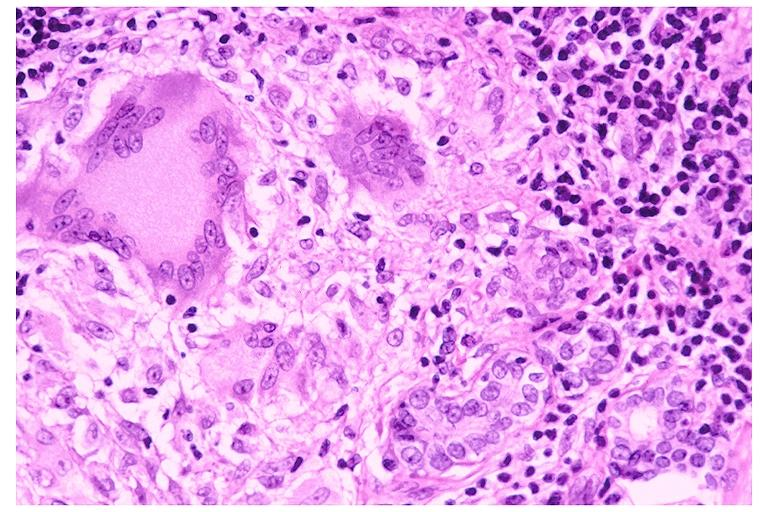where is this?
Answer the question using a single word or phrase. Oral 